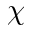<formula> <loc_0><loc_0><loc_500><loc_500>\chi</formula> 